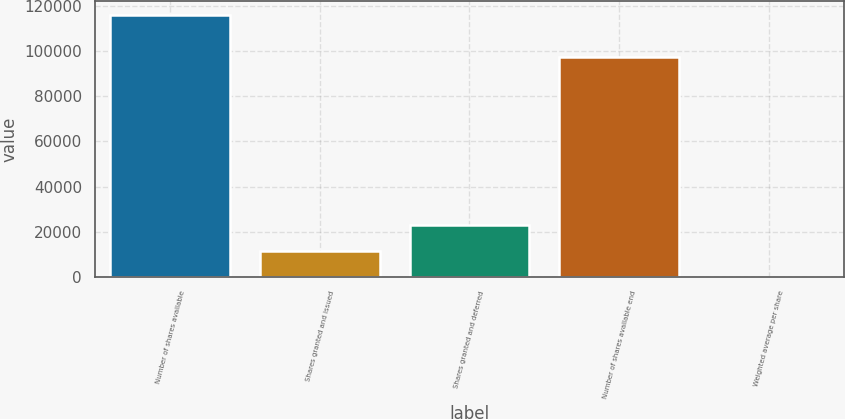Convert chart. <chart><loc_0><loc_0><loc_500><loc_500><bar_chart><fcel>Number of shares available<fcel>Shares granted and issued<fcel>Shares granted and deferred<fcel>Number of shares available end<fcel>Weighted average per share<nl><fcel>116178<fcel>11639.4<fcel>23254.8<fcel>97390<fcel>23.96<nl></chart> 